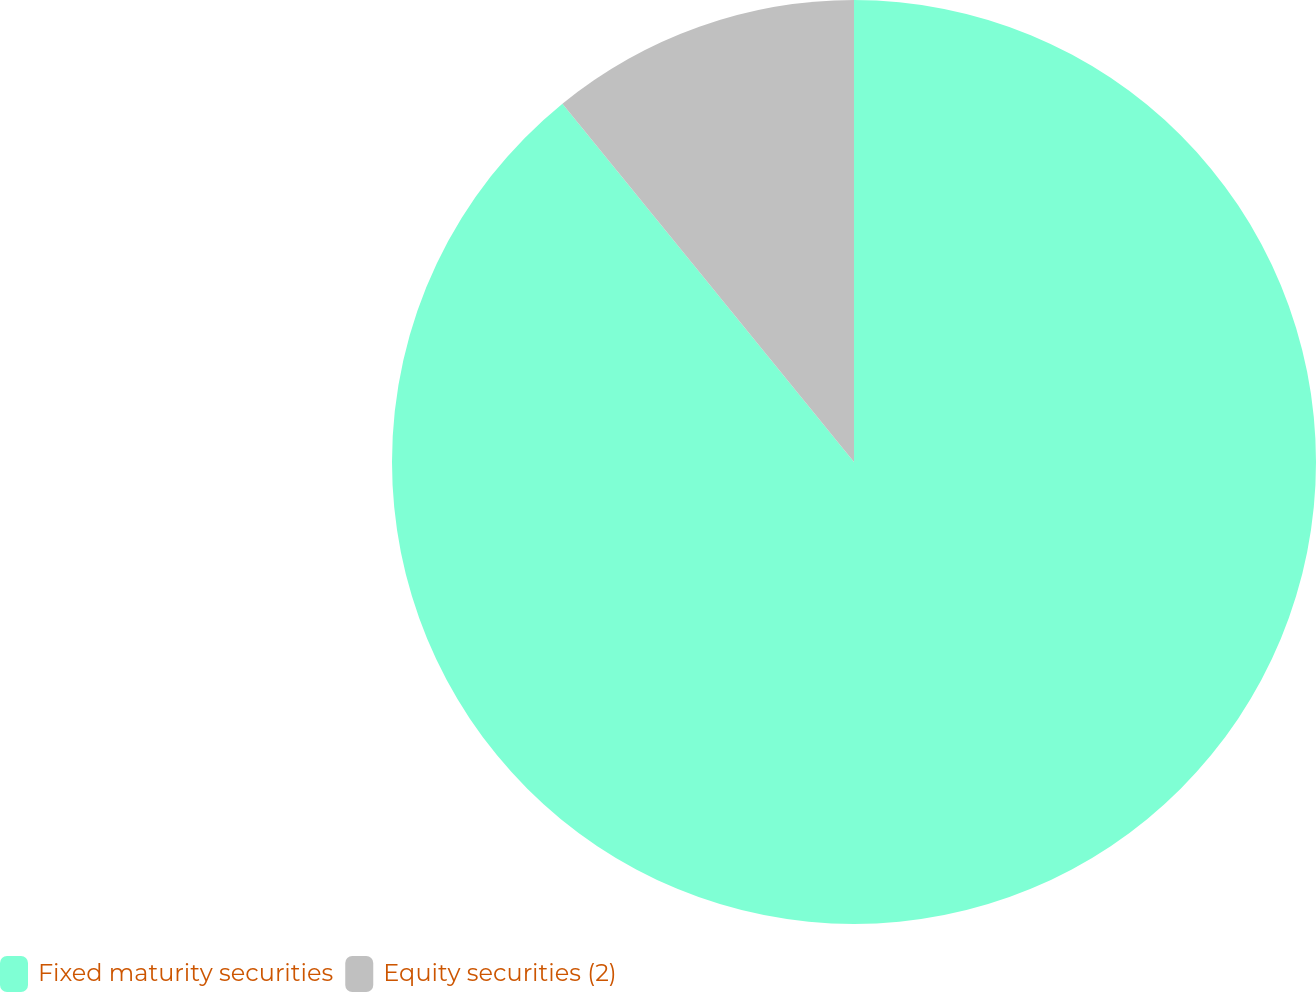Convert chart to OTSL. <chart><loc_0><loc_0><loc_500><loc_500><pie_chart><fcel>Fixed maturity securities<fcel>Equity securities (2)<nl><fcel>89.13%<fcel>10.87%<nl></chart> 